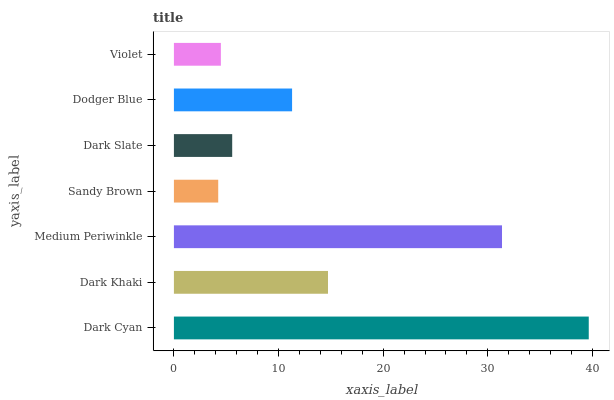Is Sandy Brown the minimum?
Answer yes or no. Yes. Is Dark Cyan the maximum?
Answer yes or no. Yes. Is Dark Khaki the minimum?
Answer yes or no. No. Is Dark Khaki the maximum?
Answer yes or no. No. Is Dark Cyan greater than Dark Khaki?
Answer yes or no. Yes. Is Dark Khaki less than Dark Cyan?
Answer yes or no. Yes. Is Dark Khaki greater than Dark Cyan?
Answer yes or no. No. Is Dark Cyan less than Dark Khaki?
Answer yes or no. No. Is Dodger Blue the high median?
Answer yes or no. Yes. Is Dodger Blue the low median?
Answer yes or no. Yes. Is Sandy Brown the high median?
Answer yes or no. No. Is Violet the low median?
Answer yes or no. No. 